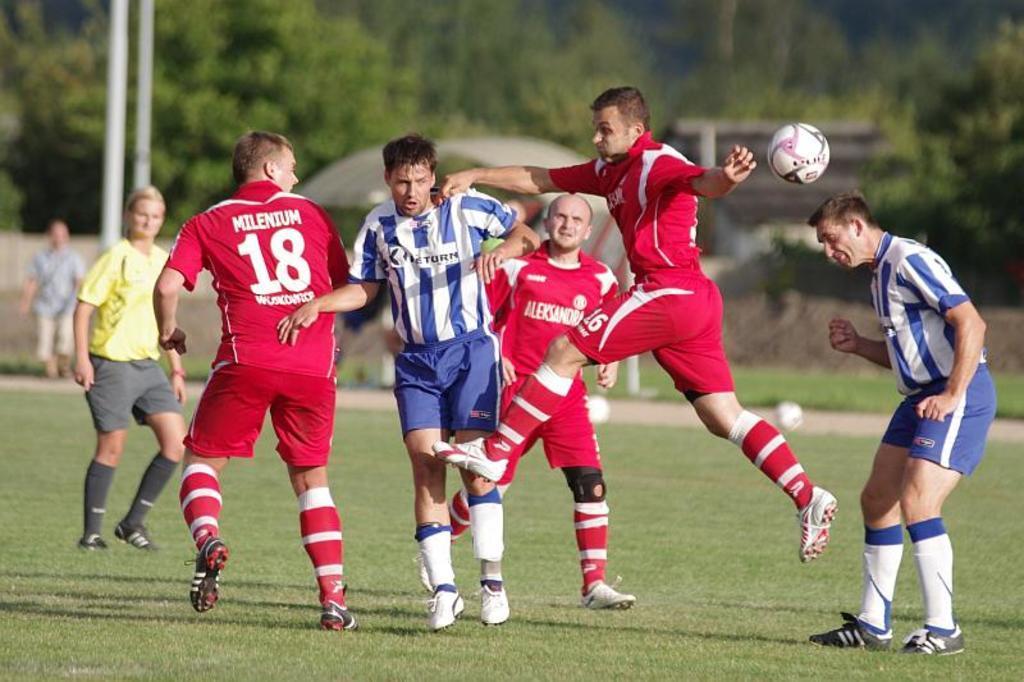Can you describe this image briefly? In this picture we can see a person jumping in the air. We can see a ball in the air. There is a man standing on the right side. We can see a few people walking on the grass. There are poles, few objects and trees in the background. Background is blurry. 